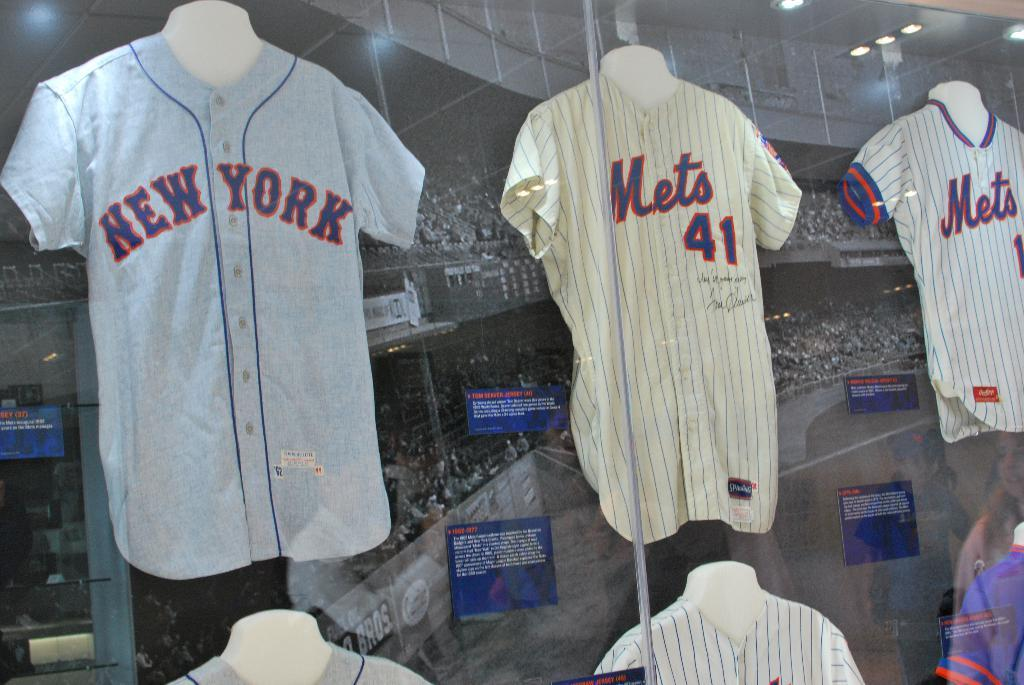<image>
Summarize the visual content of the image. Sports team shirts hanging that are white with Mets printed on the front. 